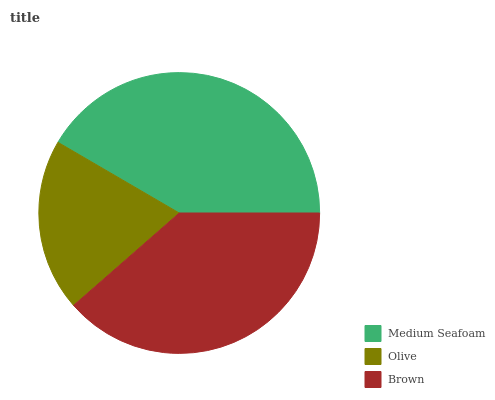Is Olive the minimum?
Answer yes or no. Yes. Is Medium Seafoam the maximum?
Answer yes or no. Yes. Is Brown the minimum?
Answer yes or no. No. Is Brown the maximum?
Answer yes or no. No. Is Brown greater than Olive?
Answer yes or no. Yes. Is Olive less than Brown?
Answer yes or no. Yes. Is Olive greater than Brown?
Answer yes or no. No. Is Brown less than Olive?
Answer yes or no. No. Is Brown the high median?
Answer yes or no. Yes. Is Brown the low median?
Answer yes or no. Yes. Is Olive the high median?
Answer yes or no. No. Is Medium Seafoam the low median?
Answer yes or no. No. 